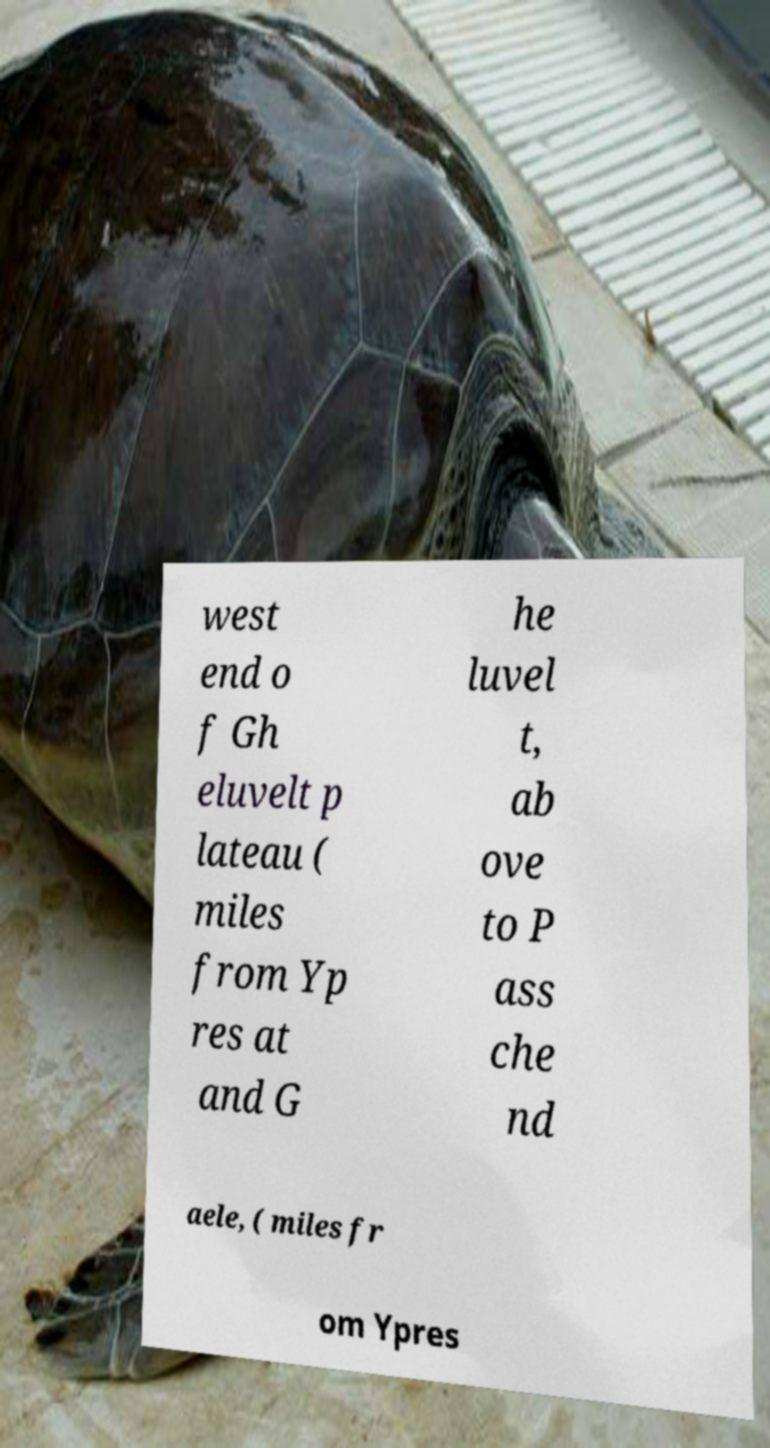Please identify and transcribe the text found in this image. west end o f Gh eluvelt p lateau ( miles from Yp res at and G he luvel t, ab ove to P ass che nd aele, ( miles fr om Ypres 